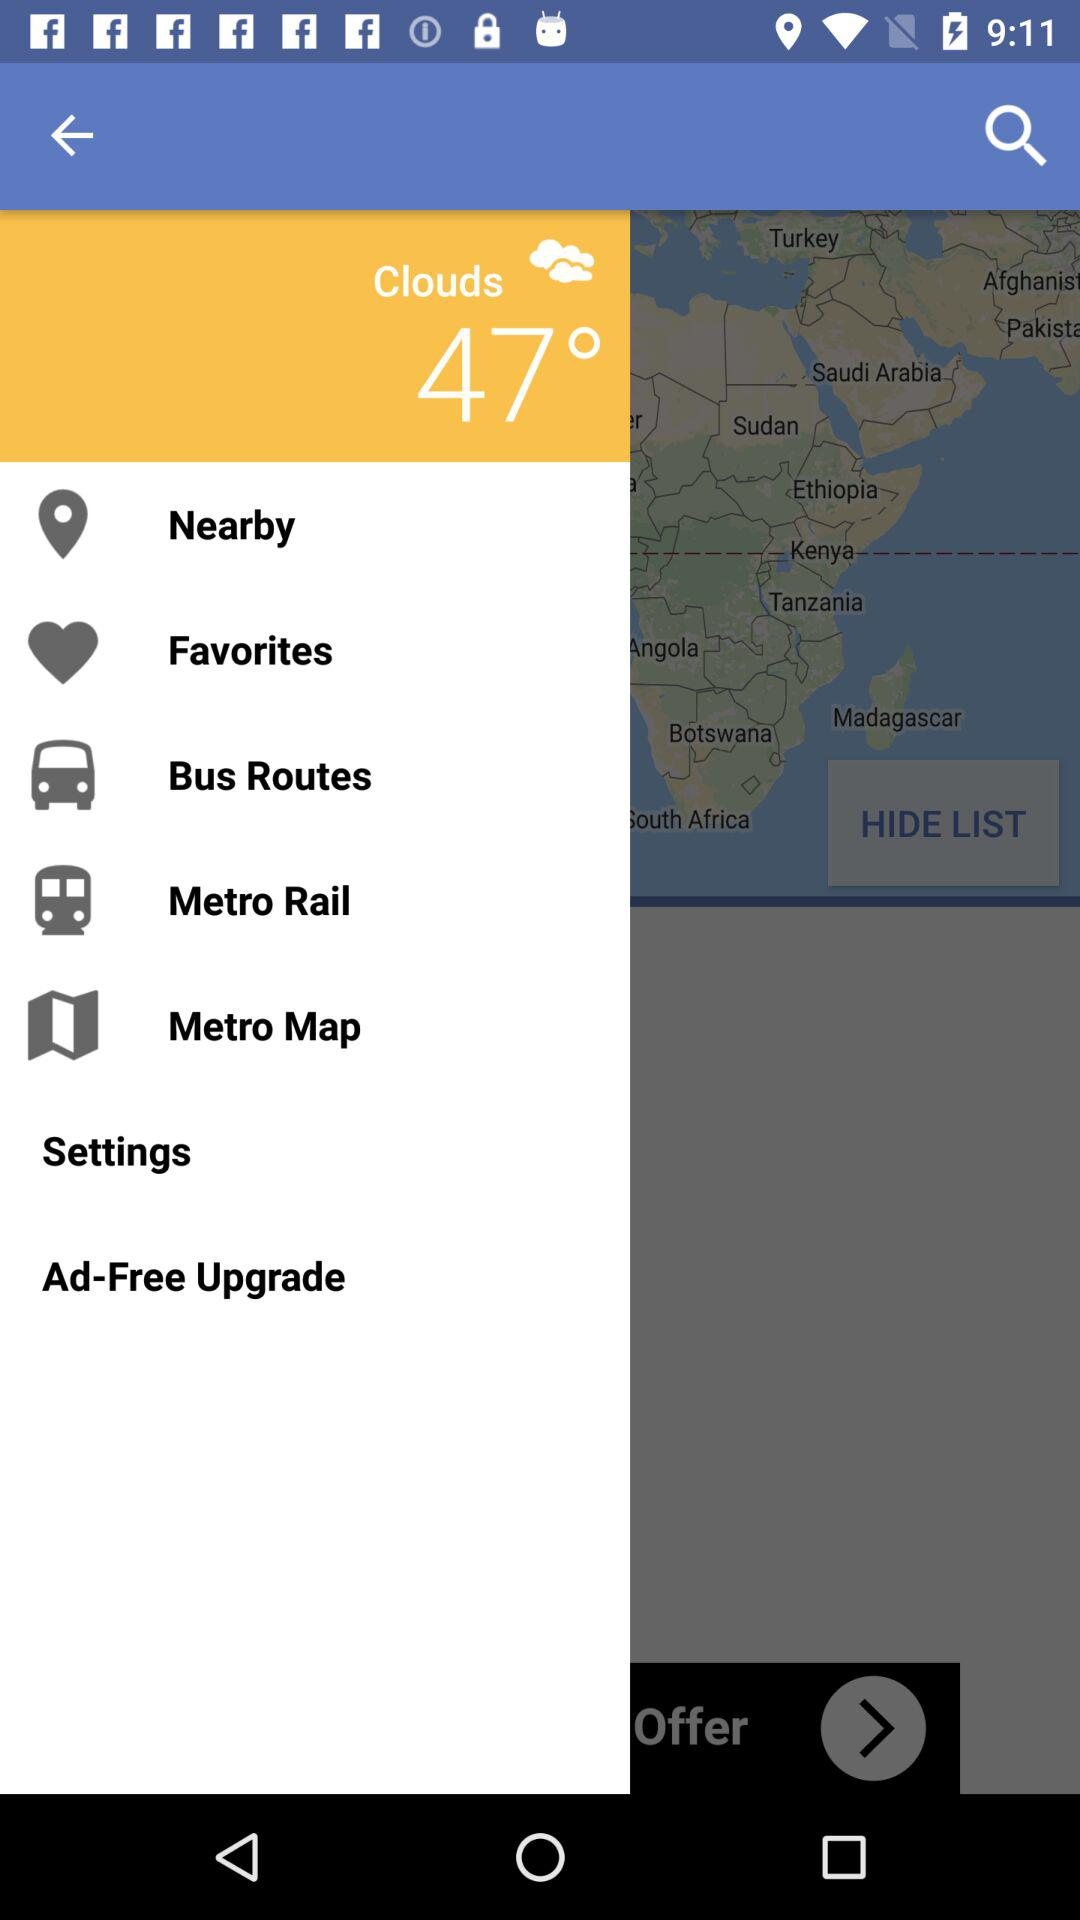What is the weather forecast? The weather forecast is cloudy. 